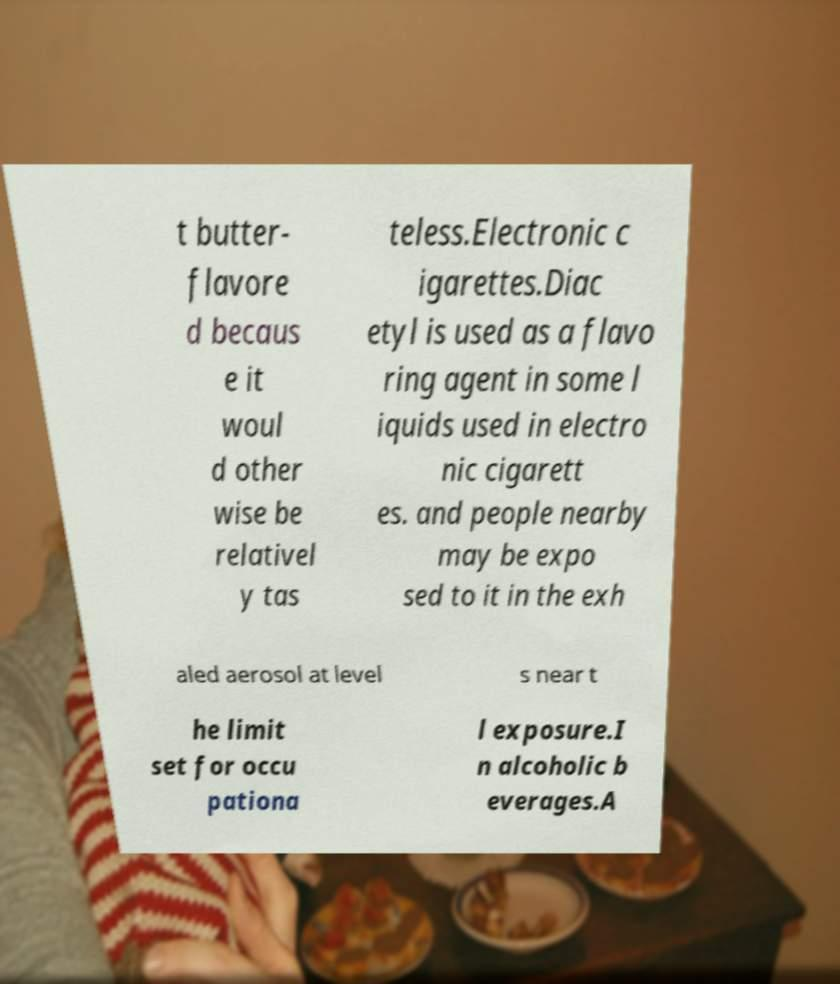There's text embedded in this image that I need extracted. Can you transcribe it verbatim? t butter- flavore d becaus e it woul d other wise be relativel y tas teless.Electronic c igarettes.Diac etyl is used as a flavo ring agent in some l iquids used in electro nic cigarett es. and people nearby may be expo sed to it in the exh aled aerosol at level s near t he limit set for occu pationa l exposure.I n alcoholic b everages.A 